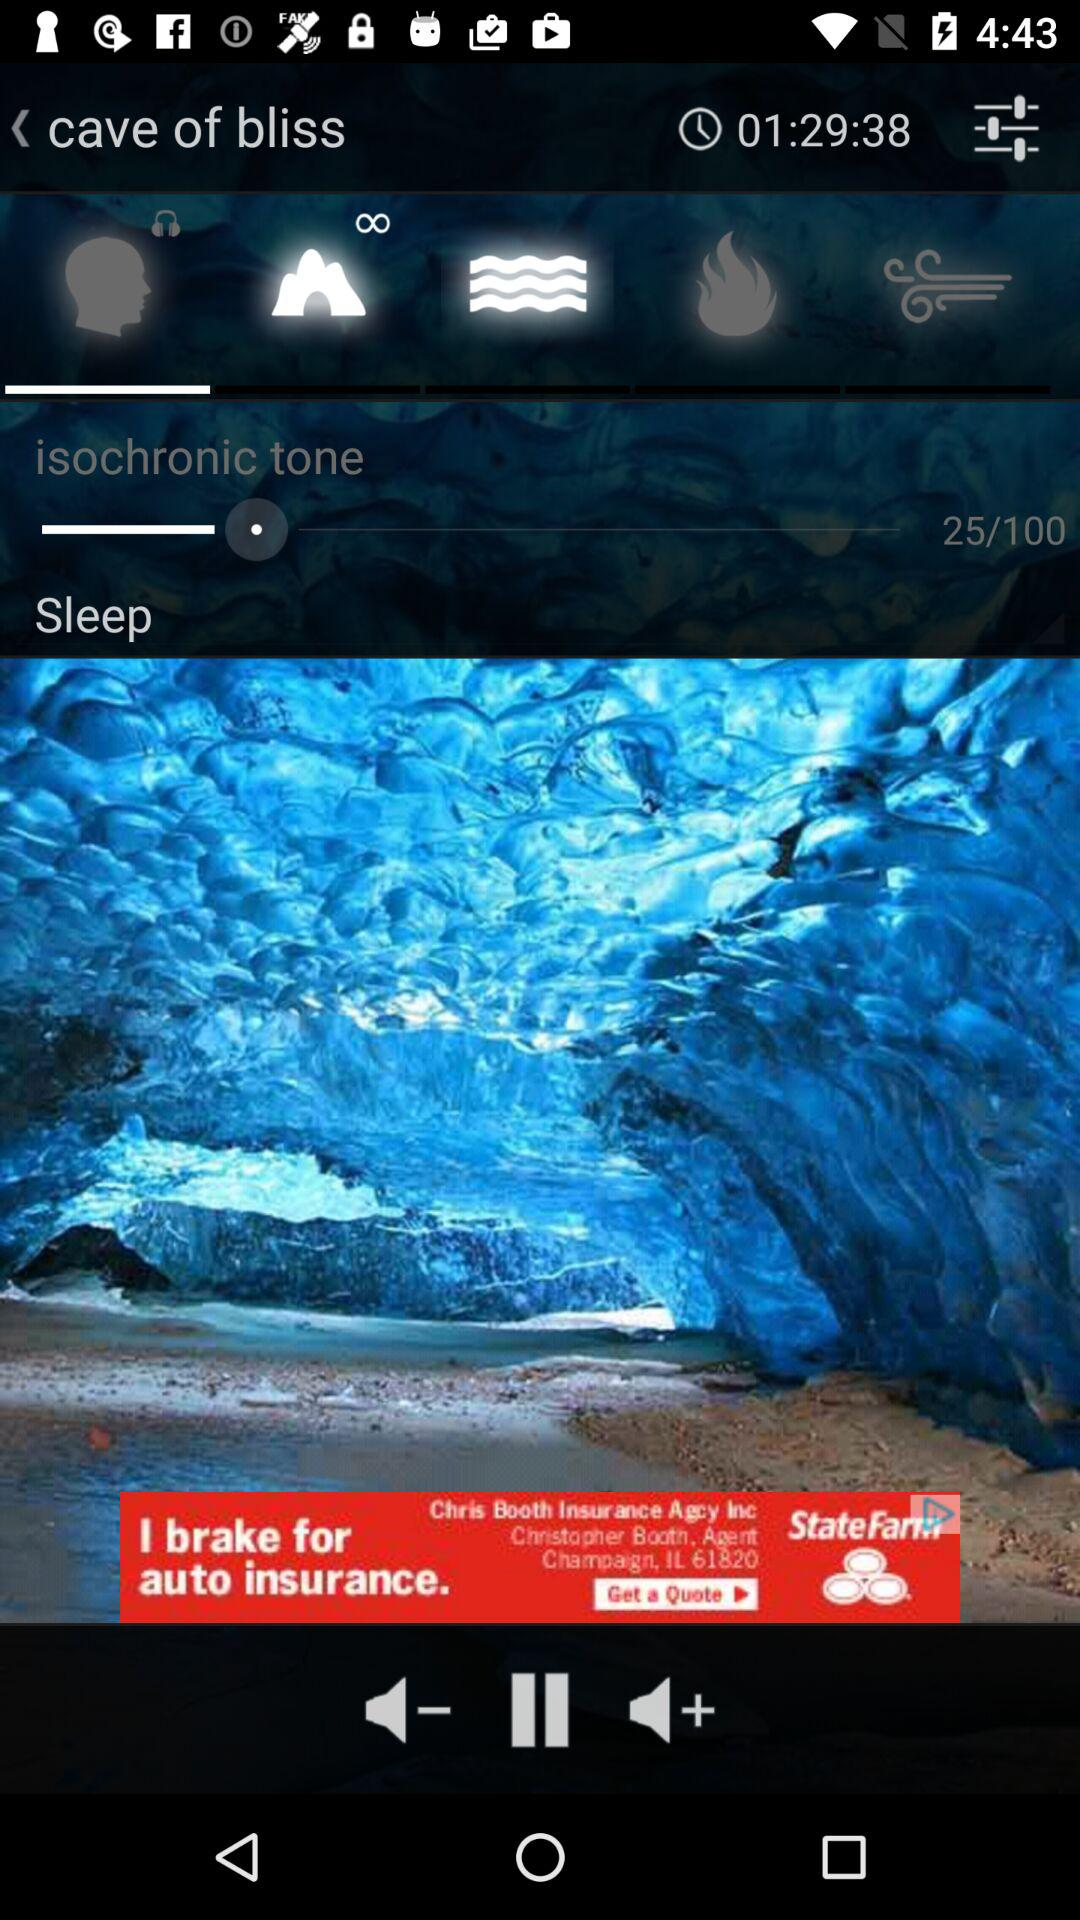What is the duration of the "cave of bliss"? The duration of the "cave of bliss" is 1 hour 29 minutes 38 seconds. 